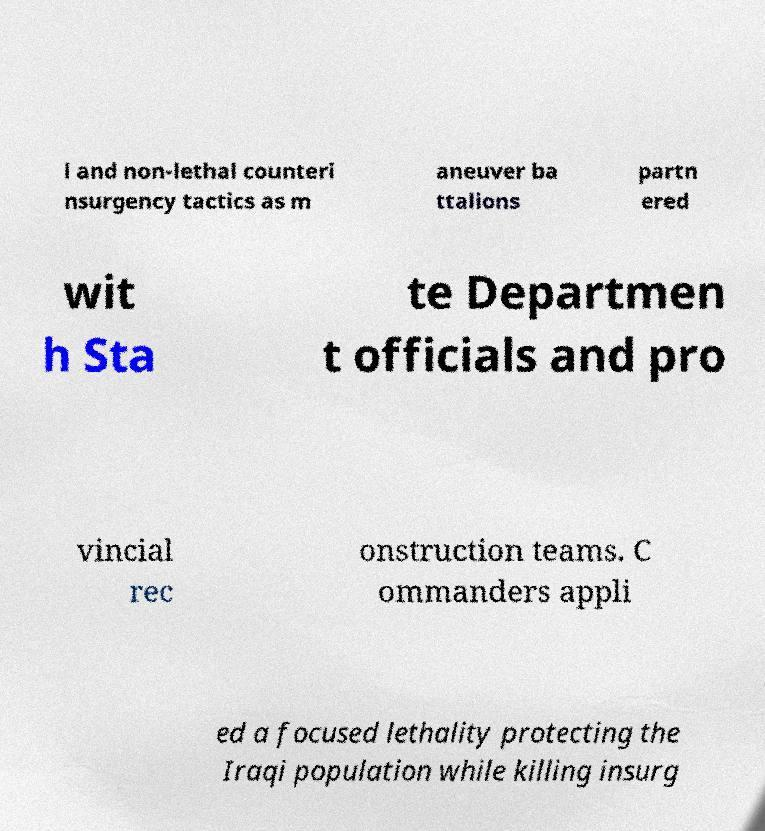There's text embedded in this image that I need extracted. Can you transcribe it verbatim? l and non-lethal counteri nsurgency tactics as m aneuver ba ttalions partn ered wit h Sta te Departmen t officials and pro vincial rec onstruction teams. C ommanders appli ed a focused lethality protecting the Iraqi population while killing insurg 